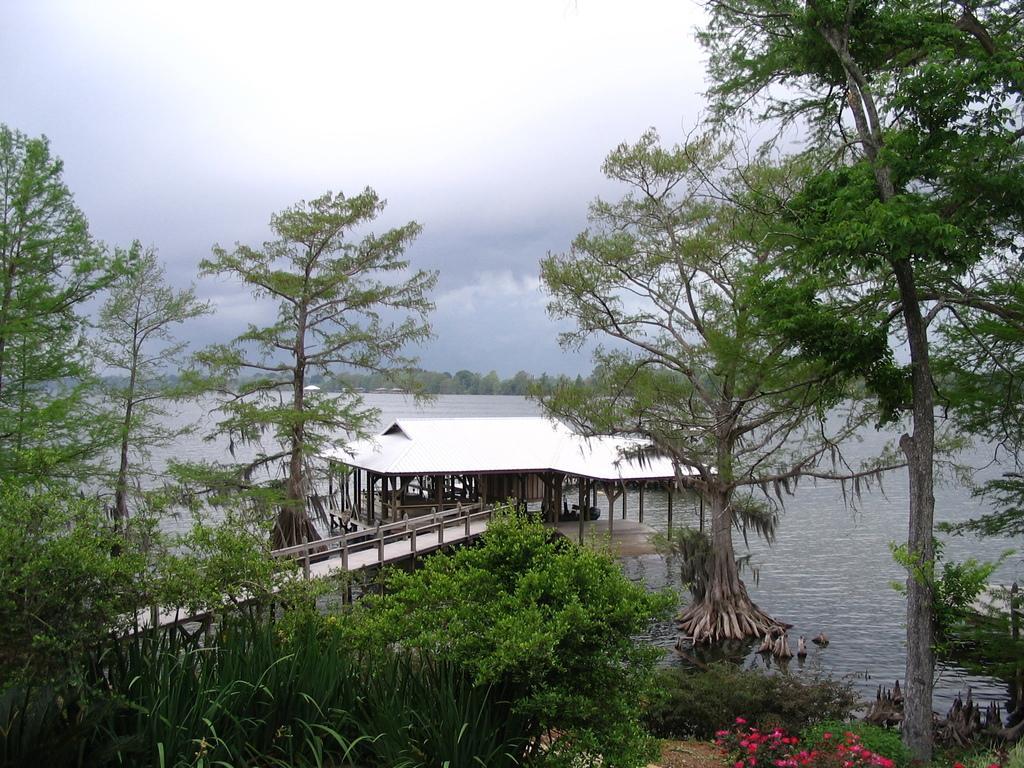How would you summarize this image in a sentence or two? In this image I can see few trees, few flowers which are red in color, a bridge which is made up of wood, the water and the house. In the background I can see few trees and the sky. 